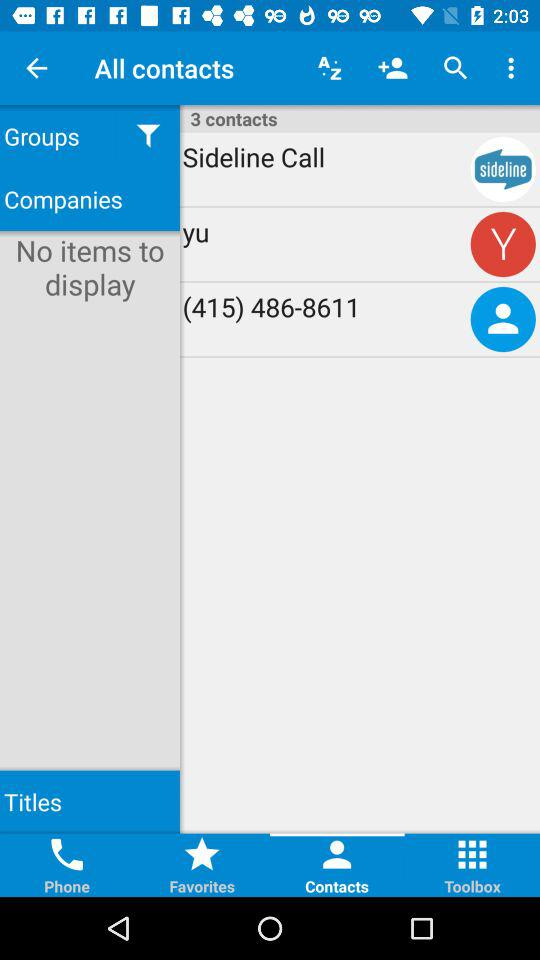What is the contact number? The contact number is (415) 486-8611. 